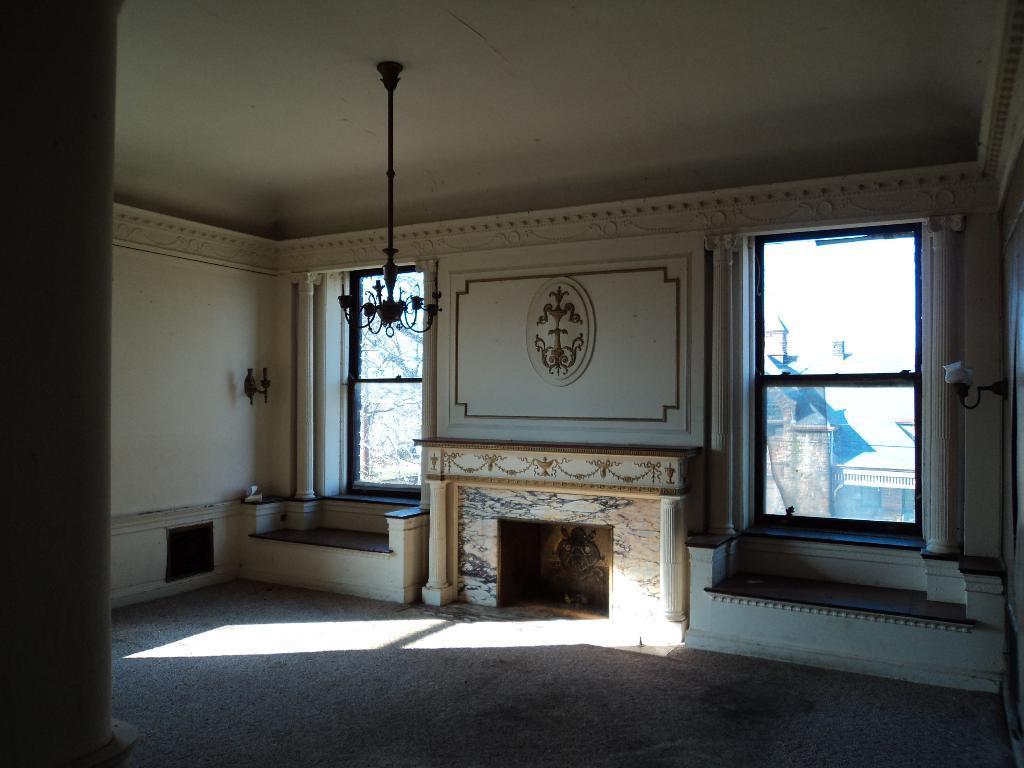In one or two sentences, can you explain what this image depicts? This image is inside a room where we can see the fireplace, wall design, lamp, chandelier and glass windows through which we can see the buildings and trees here. 